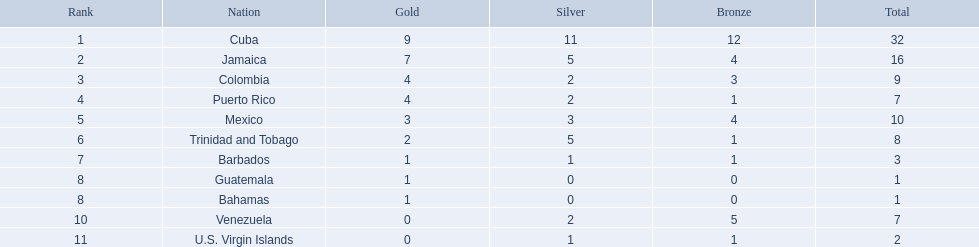In which top three countries were the most medals won? Cuba, Jamaica, Colombia. Out of these, which are islands? Cuba, Jamaica. Which country claimed the most silver medals? Cuba. 